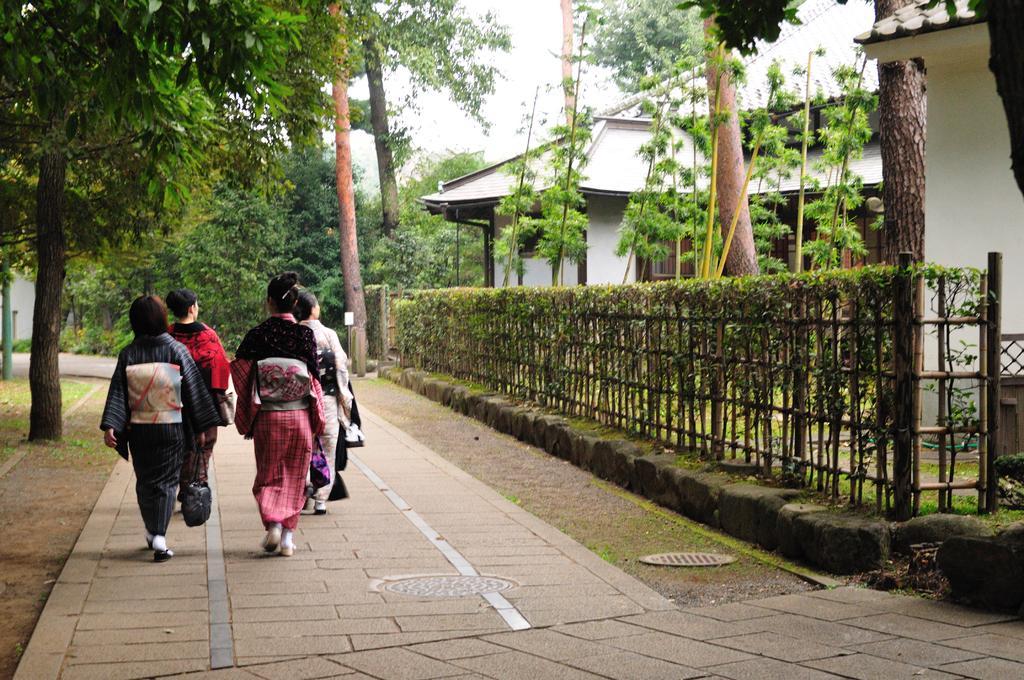In one or two sentences, can you explain what this image depicts? In this picture we can see the sky, trees, a house, roof top, plants, wooden fence. We can see the people walking on the floor. Far, on the left side of the picture we can see a green pole. 